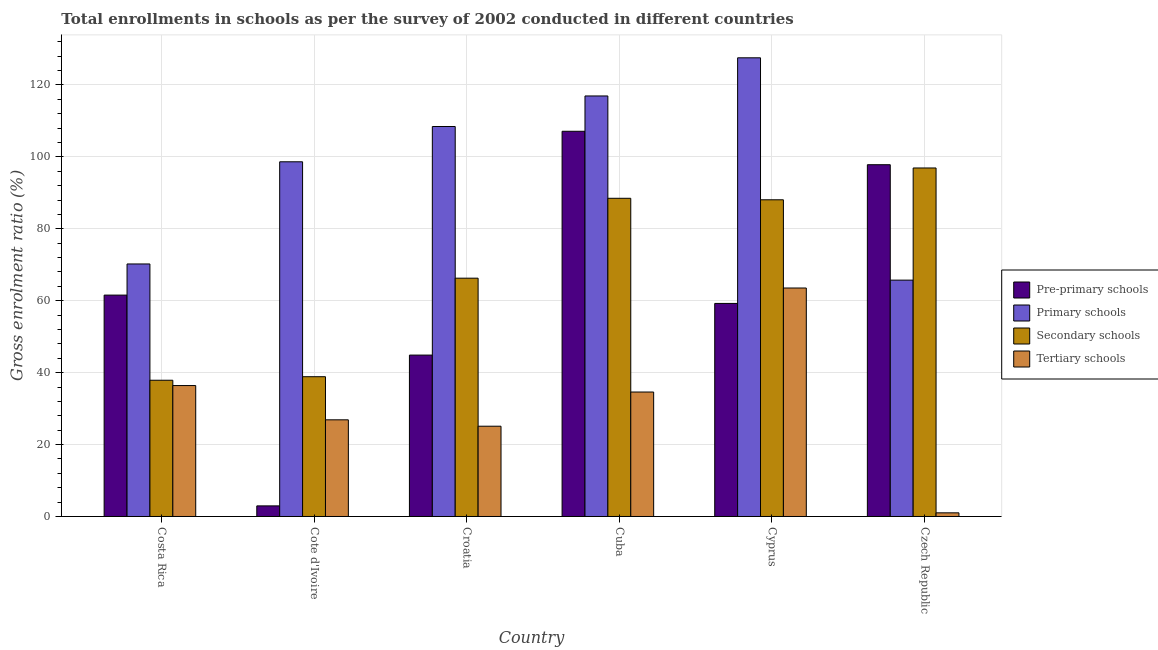How many different coloured bars are there?
Your answer should be compact. 4. Are the number of bars on each tick of the X-axis equal?
Give a very brief answer. Yes. How many bars are there on the 6th tick from the right?
Your response must be concise. 4. What is the label of the 2nd group of bars from the left?
Keep it short and to the point. Cote d'Ivoire. In how many cases, is the number of bars for a given country not equal to the number of legend labels?
Your answer should be compact. 0. What is the gross enrolment ratio in secondary schools in Cuba?
Provide a short and direct response. 88.49. Across all countries, what is the maximum gross enrolment ratio in tertiary schools?
Keep it short and to the point. 63.54. Across all countries, what is the minimum gross enrolment ratio in primary schools?
Offer a terse response. 65.73. In which country was the gross enrolment ratio in secondary schools maximum?
Provide a succinct answer. Czech Republic. In which country was the gross enrolment ratio in secondary schools minimum?
Give a very brief answer. Costa Rica. What is the total gross enrolment ratio in secondary schools in the graph?
Offer a terse response. 416.49. What is the difference between the gross enrolment ratio in pre-primary schools in Costa Rica and that in Croatia?
Provide a succinct answer. 16.68. What is the difference between the gross enrolment ratio in secondary schools in Croatia and the gross enrolment ratio in primary schools in Cuba?
Make the answer very short. -50.67. What is the average gross enrolment ratio in secondary schools per country?
Your answer should be compact. 69.42. What is the difference between the gross enrolment ratio in tertiary schools and gross enrolment ratio in primary schools in Costa Rica?
Offer a terse response. -33.81. In how many countries, is the gross enrolment ratio in primary schools greater than 72 %?
Offer a very short reply. 4. What is the ratio of the gross enrolment ratio in primary schools in Cote d'Ivoire to that in Cuba?
Provide a succinct answer. 0.84. Is the gross enrolment ratio in pre-primary schools in Cuba less than that in Cyprus?
Make the answer very short. No. What is the difference between the highest and the second highest gross enrolment ratio in primary schools?
Ensure brevity in your answer.  10.61. What is the difference between the highest and the lowest gross enrolment ratio in secondary schools?
Provide a succinct answer. 59.03. In how many countries, is the gross enrolment ratio in secondary schools greater than the average gross enrolment ratio in secondary schools taken over all countries?
Offer a very short reply. 3. What does the 2nd bar from the left in Czech Republic represents?
Offer a very short reply. Primary schools. What does the 3rd bar from the right in Cyprus represents?
Offer a terse response. Primary schools. Is it the case that in every country, the sum of the gross enrolment ratio in pre-primary schools and gross enrolment ratio in primary schools is greater than the gross enrolment ratio in secondary schools?
Make the answer very short. Yes. How many bars are there?
Provide a succinct answer. 24. Are all the bars in the graph horizontal?
Give a very brief answer. No. How many countries are there in the graph?
Make the answer very short. 6. Are the values on the major ticks of Y-axis written in scientific E-notation?
Ensure brevity in your answer.  No. Does the graph contain any zero values?
Offer a terse response. No. Where does the legend appear in the graph?
Provide a short and direct response. Center right. How many legend labels are there?
Your answer should be very brief. 4. What is the title of the graph?
Offer a very short reply. Total enrollments in schools as per the survey of 2002 conducted in different countries. Does "UNRWA" appear as one of the legend labels in the graph?
Your answer should be compact. No. What is the label or title of the X-axis?
Keep it short and to the point. Country. What is the label or title of the Y-axis?
Ensure brevity in your answer.  Gross enrolment ratio (%). What is the Gross enrolment ratio (%) in Pre-primary schools in Costa Rica?
Your answer should be compact. 61.56. What is the Gross enrolment ratio (%) in Primary schools in Costa Rica?
Your answer should be compact. 70.22. What is the Gross enrolment ratio (%) of Secondary schools in Costa Rica?
Your response must be concise. 37.89. What is the Gross enrolment ratio (%) of Tertiary schools in Costa Rica?
Give a very brief answer. 36.41. What is the Gross enrolment ratio (%) of Pre-primary schools in Cote d'Ivoire?
Your answer should be very brief. 2.95. What is the Gross enrolment ratio (%) in Primary schools in Cote d'Ivoire?
Your answer should be very brief. 98.63. What is the Gross enrolment ratio (%) of Secondary schools in Cote d'Ivoire?
Your answer should be compact. 38.87. What is the Gross enrolment ratio (%) in Tertiary schools in Cote d'Ivoire?
Your answer should be very brief. 26.88. What is the Gross enrolment ratio (%) in Pre-primary schools in Croatia?
Ensure brevity in your answer.  44.88. What is the Gross enrolment ratio (%) of Primary schools in Croatia?
Your answer should be very brief. 108.45. What is the Gross enrolment ratio (%) of Secondary schools in Croatia?
Ensure brevity in your answer.  66.27. What is the Gross enrolment ratio (%) in Tertiary schools in Croatia?
Provide a short and direct response. 25.1. What is the Gross enrolment ratio (%) in Pre-primary schools in Cuba?
Make the answer very short. 107.12. What is the Gross enrolment ratio (%) in Primary schools in Cuba?
Your answer should be very brief. 116.94. What is the Gross enrolment ratio (%) in Secondary schools in Cuba?
Ensure brevity in your answer.  88.49. What is the Gross enrolment ratio (%) of Tertiary schools in Cuba?
Provide a succinct answer. 34.61. What is the Gross enrolment ratio (%) in Pre-primary schools in Cyprus?
Ensure brevity in your answer.  59.25. What is the Gross enrolment ratio (%) of Primary schools in Cyprus?
Provide a short and direct response. 127.55. What is the Gross enrolment ratio (%) in Secondary schools in Cyprus?
Provide a succinct answer. 88.07. What is the Gross enrolment ratio (%) in Tertiary schools in Cyprus?
Provide a short and direct response. 63.54. What is the Gross enrolment ratio (%) in Pre-primary schools in Czech Republic?
Your answer should be very brief. 97.82. What is the Gross enrolment ratio (%) in Primary schools in Czech Republic?
Provide a succinct answer. 65.73. What is the Gross enrolment ratio (%) in Secondary schools in Czech Republic?
Provide a short and direct response. 96.92. What is the Gross enrolment ratio (%) of Tertiary schools in Czech Republic?
Make the answer very short. 1.02. Across all countries, what is the maximum Gross enrolment ratio (%) in Pre-primary schools?
Your answer should be compact. 107.12. Across all countries, what is the maximum Gross enrolment ratio (%) of Primary schools?
Ensure brevity in your answer.  127.55. Across all countries, what is the maximum Gross enrolment ratio (%) in Secondary schools?
Ensure brevity in your answer.  96.92. Across all countries, what is the maximum Gross enrolment ratio (%) in Tertiary schools?
Provide a succinct answer. 63.54. Across all countries, what is the minimum Gross enrolment ratio (%) of Pre-primary schools?
Your answer should be very brief. 2.95. Across all countries, what is the minimum Gross enrolment ratio (%) of Primary schools?
Keep it short and to the point. 65.73. Across all countries, what is the minimum Gross enrolment ratio (%) in Secondary schools?
Offer a very short reply. 37.89. Across all countries, what is the minimum Gross enrolment ratio (%) in Tertiary schools?
Offer a terse response. 1.02. What is the total Gross enrolment ratio (%) in Pre-primary schools in the graph?
Keep it short and to the point. 373.58. What is the total Gross enrolment ratio (%) in Primary schools in the graph?
Offer a very short reply. 587.52. What is the total Gross enrolment ratio (%) in Secondary schools in the graph?
Make the answer very short. 416.49. What is the total Gross enrolment ratio (%) of Tertiary schools in the graph?
Offer a terse response. 187.55. What is the difference between the Gross enrolment ratio (%) in Pre-primary schools in Costa Rica and that in Cote d'Ivoire?
Give a very brief answer. 58.62. What is the difference between the Gross enrolment ratio (%) in Primary schools in Costa Rica and that in Cote d'Ivoire?
Your answer should be very brief. -28.41. What is the difference between the Gross enrolment ratio (%) in Secondary schools in Costa Rica and that in Cote d'Ivoire?
Your answer should be very brief. -0.98. What is the difference between the Gross enrolment ratio (%) in Tertiary schools in Costa Rica and that in Cote d'Ivoire?
Keep it short and to the point. 9.53. What is the difference between the Gross enrolment ratio (%) of Pre-primary schools in Costa Rica and that in Croatia?
Keep it short and to the point. 16.68. What is the difference between the Gross enrolment ratio (%) in Primary schools in Costa Rica and that in Croatia?
Keep it short and to the point. -38.23. What is the difference between the Gross enrolment ratio (%) of Secondary schools in Costa Rica and that in Croatia?
Provide a succinct answer. -28.38. What is the difference between the Gross enrolment ratio (%) of Tertiary schools in Costa Rica and that in Croatia?
Offer a terse response. 11.31. What is the difference between the Gross enrolment ratio (%) of Pre-primary schools in Costa Rica and that in Cuba?
Keep it short and to the point. -45.56. What is the difference between the Gross enrolment ratio (%) of Primary schools in Costa Rica and that in Cuba?
Make the answer very short. -46.72. What is the difference between the Gross enrolment ratio (%) in Secondary schools in Costa Rica and that in Cuba?
Provide a succinct answer. -50.6. What is the difference between the Gross enrolment ratio (%) of Tertiary schools in Costa Rica and that in Cuba?
Make the answer very short. 1.8. What is the difference between the Gross enrolment ratio (%) in Pre-primary schools in Costa Rica and that in Cyprus?
Make the answer very short. 2.32. What is the difference between the Gross enrolment ratio (%) in Primary schools in Costa Rica and that in Cyprus?
Provide a succinct answer. -57.33. What is the difference between the Gross enrolment ratio (%) of Secondary schools in Costa Rica and that in Cyprus?
Your answer should be compact. -50.18. What is the difference between the Gross enrolment ratio (%) of Tertiary schools in Costa Rica and that in Cyprus?
Your answer should be compact. -27.13. What is the difference between the Gross enrolment ratio (%) of Pre-primary schools in Costa Rica and that in Czech Republic?
Offer a terse response. -36.26. What is the difference between the Gross enrolment ratio (%) of Primary schools in Costa Rica and that in Czech Republic?
Give a very brief answer. 4.5. What is the difference between the Gross enrolment ratio (%) of Secondary schools in Costa Rica and that in Czech Republic?
Offer a terse response. -59.03. What is the difference between the Gross enrolment ratio (%) of Tertiary schools in Costa Rica and that in Czech Republic?
Make the answer very short. 35.39. What is the difference between the Gross enrolment ratio (%) in Pre-primary schools in Cote d'Ivoire and that in Croatia?
Provide a succinct answer. -41.93. What is the difference between the Gross enrolment ratio (%) in Primary schools in Cote d'Ivoire and that in Croatia?
Keep it short and to the point. -9.81. What is the difference between the Gross enrolment ratio (%) in Secondary schools in Cote d'Ivoire and that in Croatia?
Make the answer very short. -27.4. What is the difference between the Gross enrolment ratio (%) in Tertiary schools in Cote d'Ivoire and that in Croatia?
Ensure brevity in your answer.  1.78. What is the difference between the Gross enrolment ratio (%) of Pre-primary schools in Cote d'Ivoire and that in Cuba?
Ensure brevity in your answer.  -104.17. What is the difference between the Gross enrolment ratio (%) of Primary schools in Cote d'Ivoire and that in Cuba?
Keep it short and to the point. -18.31. What is the difference between the Gross enrolment ratio (%) of Secondary schools in Cote d'Ivoire and that in Cuba?
Ensure brevity in your answer.  -49.62. What is the difference between the Gross enrolment ratio (%) in Tertiary schools in Cote d'Ivoire and that in Cuba?
Keep it short and to the point. -7.73. What is the difference between the Gross enrolment ratio (%) in Pre-primary schools in Cote d'Ivoire and that in Cyprus?
Your answer should be compact. -56.3. What is the difference between the Gross enrolment ratio (%) in Primary schools in Cote d'Ivoire and that in Cyprus?
Your response must be concise. -28.92. What is the difference between the Gross enrolment ratio (%) of Secondary schools in Cote d'Ivoire and that in Cyprus?
Offer a very short reply. -49.2. What is the difference between the Gross enrolment ratio (%) of Tertiary schools in Cote d'Ivoire and that in Cyprus?
Offer a terse response. -36.66. What is the difference between the Gross enrolment ratio (%) in Pre-primary schools in Cote d'Ivoire and that in Czech Republic?
Your answer should be very brief. -94.87. What is the difference between the Gross enrolment ratio (%) of Primary schools in Cote d'Ivoire and that in Czech Republic?
Make the answer very short. 32.91. What is the difference between the Gross enrolment ratio (%) in Secondary schools in Cote d'Ivoire and that in Czech Republic?
Your answer should be compact. -58.04. What is the difference between the Gross enrolment ratio (%) in Tertiary schools in Cote d'Ivoire and that in Czech Republic?
Offer a terse response. 25.86. What is the difference between the Gross enrolment ratio (%) of Pre-primary schools in Croatia and that in Cuba?
Give a very brief answer. -62.24. What is the difference between the Gross enrolment ratio (%) in Primary schools in Croatia and that in Cuba?
Your response must be concise. -8.49. What is the difference between the Gross enrolment ratio (%) in Secondary schools in Croatia and that in Cuba?
Provide a short and direct response. -22.22. What is the difference between the Gross enrolment ratio (%) in Tertiary schools in Croatia and that in Cuba?
Provide a succinct answer. -9.51. What is the difference between the Gross enrolment ratio (%) in Pre-primary schools in Croatia and that in Cyprus?
Ensure brevity in your answer.  -14.37. What is the difference between the Gross enrolment ratio (%) in Primary schools in Croatia and that in Cyprus?
Your response must be concise. -19.1. What is the difference between the Gross enrolment ratio (%) of Secondary schools in Croatia and that in Cyprus?
Keep it short and to the point. -21.8. What is the difference between the Gross enrolment ratio (%) in Tertiary schools in Croatia and that in Cyprus?
Provide a short and direct response. -38.43. What is the difference between the Gross enrolment ratio (%) of Pre-primary schools in Croatia and that in Czech Republic?
Provide a short and direct response. -52.94. What is the difference between the Gross enrolment ratio (%) in Primary schools in Croatia and that in Czech Republic?
Your answer should be very brief. 42.72. What is the difference between the Gross enrolment ratio (%) in Secondary schools in Croatia and that in Czech Republic?
Your answer should be very brief. -30.65. What is the difference between the Gross enrolment ratio (%) of Tertiary schools in Croatia and that in Czech Republic?
Your answer should be compact. 24.09. What is the difference between the Gross enrolment ratio (%) of Pre-primary schools in Cuba and that in Cyprus?
Provide a succinct answer. 47.87. What is the difference between the Gross enrolment ratio (%) of Primary schools in Cuba and that in Cyprus?
Keep it short and to the point. -10.61. What is the difference between the Gross enrolment ratio (%) in Secondary schools in Cuba and that in Cyprus?
Give a very brief answer. 0.42. What is the difference between the Gross enrolment ratio (%) of Tertiary schools in Cuba and that in Cyprus?
Ensure brevity in your answer.  -28.93. What is the difference between the Gross enrolment ratio (%) in Pre-primary schools in Cuba and that in Czech Republic?
Your answer should be compact. 9.3. What is the difference between the Gross enrolment ratio (%) of Primary schools in Cuba and that in Czech Republic?
Your answer should be compact. 51.22. What is the difference between the Gross enrolment ratio (%) in Secondary schools in Cuba and that in Czech Republic?
Offer a very short reply. -8.43. What is the difference between the Gross enrolment ratio (%) of Tertiary schools in Cuba and that in Czech Republic?
Make the answer very short. 33.59. What is the difference between the Gross enrolment ratio (%) of Pre-primary schools in Cyprus and that in Czech Republic?
Offer a very short reply. -38.57. What is the difference between the Gross enrolment ratio (%) in Primary schools in Cyprus and that in Czech Republic?
Provide a succinct answer. 61.82. What is the difference between the Gross enrolment ratio (%) of Secondary schools in Cyprus and that in Czech Republic?
Give a very brief answer. -8.85. What is the difference between the Gross enrolment ratio (%) of Tertiary schools in Cyprus and that in Czech Republic?
Offer a terse response. 62.52. What is the difference between the Gross enrolment ratio (%) in Pre-primary schools in Costa Rica and the Gross enrolment ratio (%) in Primary schools in Cote d'Ivoire?
Provide a short and direct response. -37.07. What is the difference between the Gross enrolment ratio (%) of Pre-primary schools in Costa Rica and the Gross enrolment ratio (%) of Secondary schools in Cote d'Ivoire?
Provide a short and direct response. 22.69. What is the difference between the Gross enrolment ratio (%) of Pre-primary schools in Costa Rica and the Gross enrolment ratio (%) of Tertiary schools in Cote d'Ivoire?
Give a very brief answer. 34.68. What is the difference between the Gross enrolment ratio (%) in Primary schools in Costa Rica and the Gross enrolment ratio (%) in Secondary schools in Cote d'Ivoire?
Your answer should be compact. 31.35. What is the difference between the Gross enrolment ratio (%) of Primary schools in Costa Rica and the Gross enrolment ratio (%) of Tertiary schools in Cote d'Ivoire?
Your answer should be compact. 43.34. What is the difference between the Gross enrolment ratio (%) in Secondary schools in Costa Rica and the Gross enrolment ratio (%) in Tertiary schools in Cote d'Ivoire?
Offer a very short reply. 11.01. What is the difference between the Gross enrolment ratio (%) in Pre-primary schools in Costa Rica and the Gross enrolment ratio (%) in Primary schools in Croatia?
Your answer should be very brief. -46.88. What is the difference between the Gross enrolment ratio (%) in Pre-primary schools in Costa Rica and the Gross enrolment ratio (%) in Secondary schools in Croatia?
Provide a short and direct response. -4.71. What is the difference between the Gross enrolment ratio (%) in Pre-primary schools in Costa Rica and the Gross enrolment ratio (%) in Tertiary schools in Croatia?
Keep it short and to the point. 36.46. What is the difference between the Gross enrolment ratio (%) of Primary schools in Costa Rica and the Gross enrolment ratio (%) of Secondary schools in Croatia?
Provide a short and direct response. 3.95. What is the difference between the Gross enrolment ratio (%) of Primary schools in Costa Rica and the Gross enrolment ratio (%) of Tertiary schools in Croatia?
Your answer should be compact. 45.12. What is the difference between the Gross enrolment ratio (%) in Secondary schools in Costa Rica and the Gross enrolment ratio (%) in Tertiary schools in Croatia?
Keep it short and to the point. 12.78. What is the difference between the Gross enrolment ratio (%) of Pre-primary schools in Costa Rica and the Gross enrolment ratio (%) of Primary schools in Cuba?
Your answer should be compact. -55.38. What is the difference between the Gross enrolment ratio (%) in Pre-primary schools in Costa Rica and the Gross enrolment ratio (%) in Secondary schools in Cuba?
Ensure brevity in your answer.  -26.92. What is the difference between the Gross enrolment ratio (%) of Pre-primary schools in Costa Rica and the Gross enrolment ratio (%) of Tertiary schools in Cuba?
Make the answer very short. 26.95. What is the difference between the Gross enrolment ratio (%) in Primary schools in Costa Rica and the Gross enrolment ratio (%) in Secondary schools in Cuba?
Give a very brief answer. -18.26. What is the difference between the Gross enrolment ratio (%) in Primary schools in Costa Rica and the Gross enrolment ratio (%) in Tertiary schools in Cuba?
Ensure brevity in your answer.  35.61. What is the difference between the Gross enrolment ratio (%) in Secondary schools in Costa Rica and the Gross enrolment ratio (%) in Tertiary schools in Cuba?
Make the answer very short. 3.28. What is the difference between the Gross enrolment ratio (%) of Pre-primary schools in Costa Rica and the Gross enrolment ratio (%) of Primary schools in Cyprus?
Provide a short and direct response. -65.99. What is the difference between the Gross enrolment ratio (%) in Pre-primary schools in Costa Rica and the Gross enrolment ratio (%) in Secondary schools in Cyprus?
Offer a terse response. -26.5. What is the difference between the Gross enrolment ratio (%) in Pre-primary schools in Costa Rica and the Gross enrolment ratio (%) in Tertiary schools in Cyprus?
Ensure brevity in your answer.  -1.97. What is the difference between the Gross enrolment ratio (%) in Primary schools in Costa Rica and the Gross enrolment ratio (%) in Secondary schools in Cyprus?
Your answer should be very brief. -17.84. What is the difference between the Gross enrolment ratio (%) in Primary schools in Costa Rica and the Gross enrolment ratio (%) in Tertiary schools in Cyprus?
Provide a short and direct response. 6.69. What is the difference between the Gross enrolment ratio (%) of Secondary schools in Costa Rica and the Gross enrolment ratio (%) of Tertiary schools in Cyprus?
Your answer should be very brief. -25.65. What is the difference between the Gross enrolment ratio (%) in Pre-primary schools in Costa Rica and the Gross enrolment ratio (%) in Primary schools in Czech Republic?
Offer a terse response. -4.16. What is the difference between the Gross enrolment ratio (%) of Pre-primary schools in Costa Rica and the Gross enrolment ratio (%) of Secondary schools in Czech Republic?
Provide a succinct answer. -35.35. What is the difference between the Gross enrolment ratio (%) of Pre-primary schools in Costa Rica and the Gross enrolment ratio (%) of Tertiary schools in Czech Republic?
Provide a succinct answer. 60.55. What is the difference between the Gross enrolment ratio (%) of Primary schools in Costa Rica and the Gross enrolment ratio (%) of Secondary schools in Czech Republic?
Make the answer very short. -26.69. What is the difference between the Gross enrolment ratio (%) in Primary schools in Costa Rica and the Gross enrolment ratio (%) in Tertiary schools in Czech Republic?
Keep it short and to the point. 69.2. What is the difference between the Gross enrolment ratio (%) of Secondary schools in Costa Rica and the Gross enrolment ratio (%) of Tertiary schools in Czech Republic?
Offer a very short reply. 36.87. What is the difference between the Gross enrolment ratio (%) of Pre-primary schools in Cote d'Ivoire and the Gross enrolment ratio (%) of Primary schools in Croatia?
Provide a succinct answer. -105.5. What is the difference between the Gross enrolment ratio (%) of Pre-primary schools in Cote d'Ivoire and the Gross enrolment ratio (%) of Secondary schools in Croatia?
Make the answer very short. -63.32. What is the difference between the Gross enrolment ratio (%) of Pre-primary schools in Cote d'Ivoire and the Gross enrolment ratio (%) of Tertiary schools in Croatia?
Provide a short and direct response. -22.16. What is the difference between the Gross enrolment ratio (%) in Primary schools in Cote d'Ivoire and the Gross enrolment ratio (%) in Secondary schools in Croatia?
Make the answer very short. 32.36. What is the difference between the Gross enrolment ratio (%) in Primary schools in Cote d'Ivoire and the Gross enrolment ratio (%) in Tertiary schools in Croatia?
Provide a short and direct response. 73.53. What is the difference between the Gross enrolment ratio (%) in Secondary schools in Cote d'Ivoire and the Gross enrolment ratio (%) in Tertiary schools in Croatia?
Keep it short and to the point. 13.77. What is the difference between the Gross enrolment ratio (%) in Pre-primary schools in Cote d'Ivoire and the Gross enrolment ratio (%) in Primary schools in Cuba?
Make the answer very short. -113.99. What is the difference between the Gross enrolment ratio (%) of Pre-primary schools in Cote d'Ivoire and the Gross enrolment ratio (%) of Secondary schools in Cuba?
Ensure brevity in your answer.  -85.54. What is the difference between the Gross enrolment ratio (%) in Pre-primary schools in Cote d'Ivoire and the Gross enrolment ratio (%) in Tertiary schools in Cuba?
Offer a terse response. -31.66. What is the difference between the Gross enrolment ratio (%) of Primary schools in Cote d'Ivoire and the Gross enrolment ratio (%) of Secondary schools in Cuba?
Your answer should be compact. 10.15. What is the difference between the Gross enrolment ratio (%) in Primary schools in Cote d'Ivoire and the Gross enrolment ratio (%) in Tertiary schools in Cuba?
Offer a terse response. 64.02. What is the difference between the Gross enrolment ratio (%) of Secondary schools in Cote d'Ivoire and the Gross enrolment ratio (%) of Tertiary schools in Cuba?
Your response must be concise. 4.26. What is the difference between the Gross enrolment ratio (%) in Pre-primary schools in Cote d'Ivoire and the Gross enrolment ratio (%) in Primary schools in Cyprus?
Your response must be concise. -124.6. What is the difference between the Gross enrolment ratio (%) of Pre-primary schools in Cote d'Ivoire and the Gross enrolment ratio (%) of Secondary schools in Cyprus?
Make the answer very short. -85.12. What is the difference between the Gross enrolment ratio (%) of Pre-primary schools in Cote d'Ivoire and the Gross enrolment ratio (%) of Tertiary schools in Cyprus?
Ensure brevity in your answer.  -60.59. What is the difference between the Gross enrolment ratio (%) of Primary schools in Cote d'Ivoire and the Gross enrolment ratio (%) of Secondary schools in Cyprus?
Your answer should be very brief. 10.57. What is the difference between the Gross enrolment ratio (%) in Primary schools in Cote d'Ivoire and the Gross enrolment ratio (%) in Tertiary schools in Cyprus?
Give a very brief answer. 35.1. What is the difference between the Gross enrolment ratio (%) in Secondary schools in Cote d'Ivoire and the Gross enrolment ratio (%) in Tertiary schools in Cyprus?
Give a very brief answer. -24.66. What is the difference between the Gross enrolment ratio (%) of Pre-primary schools in Cote d'Ivoire and the Gross enrolment ratio (%) of Primary schools in Czech Republic?
Your answer should be very brief. -62.78. What is the difference between the Gross enrolment ratio (%) of Pre-primary schools in Cote d'Ivoire and the Gross enrolment ratio (%) of Secondary schools in Czech Republic?
Ensure brevity in your answer.  -93.97. What is the difference between the Gross enrolment ratio (%) of Pre-primary schools in Cote d'Ivoire and the Gross enrolment ratio (%) of Tertiary schools in Czech Republic?
Your response must be concise. 1.93. What is the difference between the Gross enrolment ratio (%) in Primary schools in Cote d'Ivoire and the Gross enrolment ratio (%) in Secondary schools in Czech Republic?
Your response must be concise. 1.72. What is the difference between the Gross enrolment ratio (%) in Primary schools in Cote d'Ivoire and the Gross enrolment ratio (%) in Tertiary schools in Czech Republic?
Your answer should be compact. 97.62. What is the difference between the Gross enrolment ratio (%) of Secondary schools in Cote d'Ivoire and the Gross enrolment ratio (%) of Tertiary schools in Czech Republic?
Make the answer very short. 37.85. What is the difference between the Gross enrolment ratio (%) in Pre-primary schools in Croatia and the Gross enrolment ratio (%) in Primary schools in Cuba?
Provide a short and direct response. -72.06. What is the difference between the Gross enrolment ratio (%) in Pre-primary schools in Croatia and the Gross enrolment ratio (%) in Secondary schools in Cuba?
Ensure brevity in your answer.  -43.61. What is the difference between the Gross enrolment ratio (%) of Pre-primary schools in Croatia and the Gross enrolment ratio (%) of Tertiary schools in Cuba?
Your answer should be compact. 10.27. What is the difference between the Gross enrolment ratio (%) in Primary schools in Croatia and the Gross enrolment ratio (%) in Secondary schools in Cuba?
Give a very brief answer. 19.96. What is the difference between the Gross enrolment ratio (%) in Primary schools in Croatia and the Gross enrolment ratio (%) in Tertiary schools in Cuba?
Make the answer very short. 73.84. What is the difference between the Gross enrolment ratio (%) of Secondary schools in Croatia and the Gross enrolment ratio (%) of Tertiary schools in Cuba?
Offer a terse response. 31.66. What is the difference between the Gross enrolment ratio (%) of Pre-primary schools in Croatia and the Gross enrolment ratio (%) of Primary schools in Cyprus?
Provide a short and direct response. -82.67. What is the difference between the Gross enrolment ratio (%) in Pre-primary schools in Croatia and the Gross enrolment ratio (%) in Secondary schools in Cyprus?
Offer a terse response. -43.19. What is the difference between the Gross enrolment ratio (%) of Pre-primary schools in Croatia and the Gross enrolment ratio (%) of Tertiary schools in Cyprus?
Your answer should be compact. -18.66. What is the difference between the Gross enrolment ratio (%) in Primary schools in Croatia and the Gross enrolment ratio (%) in Secondary schools in Cyprus?
Give a very brief answer. 20.38. What is the difference between the Gross enrolment ratio (%) of Primary schools in Croatia and the Gross enrolment ratio (%) of Tertiary schools in Cyprus?
Make the answer very short. 44.91. What is the difference between the Gross enrolment ratio (%) of Secondary schools in Croatia and the Gross enrolment ratio (%) of Tertiary schools in Cyprus?
Your response must be concise. 2.73. What is the difference between the Gross enrolment ratio (%) of Pre-primary schools in Croatia and the Gross enrolment ratio (%) of Primary schools in Czech Republic?
Give a very brief answer. -20.85. What is the difference between the Gross enrolment ratio (%) in Pre-primary schools in Croatia and the Gross enrolment ratio (%) in Secondary schools in Czech Republic?
Keep it short and to the point. -52.04. What is the difference between the Gross enrolment ratio (%) of Pre-primary schools in Croatia and the Gross enrolment ratio (%) of Tertiary schools in Czech Republic?
Ensure brevity in your answer.  43.86. What is the difference between the Gross enrolment ratio (%) of Primary schools in Croatia and the Gross enrolment ratio (%) of Secondary schools in Czech Republic?
Your answer should be compact. 11.53. What is the difference between the Gross enrolment ratio (%) of Primary schools in Croatia and the Gross enrolment ratio (%) of Tertiary schools in Czech Republic?
Your answer should be very brief. 107.43. What is the difference between the Gross enrolment ratio (%) of Secondary schools in Croatia and the Gross enrolment ratio (%) of Tertiary schools in Czech Republic?
Give a very brief answer. 65.25. What is the difference between the Gross enrolment ratio (%) in Pre-primary schools in Cuba and the Gross enrolment ratio (%) in Primary schools in Cyprus?
Your answer should be very brief. -20.43. What is the difference between the Gross enrolment ratio (%) of Pre-primary schools in Cuba and the Gross enrolment ratio (%) of Secondary schools in Cyprus?
Ensure brevity in your answer.  19.05. What is the difference between the Gross enrolment ratio (%) of Pre-primary schools in Cuba and the Gross enrolment ratio (%) of Tertiary schools in Cyprus?
Offer a very short reply. 43.58. What is the difference between the Gross enrolment ratio (%) of Primary schools in Cuba and the Gross enrolment ratio (%) of Secondary schools in Cyprus?
Offer a terse response. 28.88. What is the difference between the Gross enrolment ratio (%) of Primary schools in Cuba and the Gross enrolment ratio (%) of Tertiary schools in Cyprus?
Your answer should be compact. 53.41. What is the difference between the Gross enrolment ratio (%) in Secondary schools in Cuba and the Gross enrolment ratio (%) in Tertiary schools in Cyprus?
Give a very brief answer. 24.95. What is the difference between the Gross enrolment ratio (%) of Pre-primary schools in Cuba and the Gross enrolment ratio (%) of Primary schools in Czech Republic?
Provide a succinct answer. 41.39. What is the difference between the Gross enrolment ratio (%) of Pre-primary schools in Cuba and the Gross enrolment ratio (%) of Secondary schools in Czech Republic?
Offer a very short reply. 10.2. What is the difference between the Gross enrolment ratio (%) of Pre-primary schools in Cuba and the Gross enrolment ratio (%) of Tertiary schools in Czech Republic?
Offer a very short reply. 106.1. What is the difference between the Gross enrolment ratio (%) of Primary schools in Cuba and the Gross enrolment ratio (%) of Secondary schools in Czech Republic?
Provide a succinct answer. 20.03. What is the difference between the Gross enrolment ratio (%) in Primary schools in Cuba and the Gross enrolment ratio (%) in Tertiary schools in Czech Republic?
Give a very brief answer. 115.92. What is the difference between the Gross enrolment ratio (%) of Secondary schools in Cuba and the Gross enrolment ratio (%) of Tertiary schools in Czech Republic?
Offer a terse response. 87.47. What is the difference between the Gross enrolment ratio (%) of Pre-primary schools in Cyprus and the Gross enrolment ratio (%) of Primary schools in Czech Republic?
Provide a short and direct response. -6.48. What is the difference between the Gross enrolment ratio (%) in Pre-primary schools in Cyprus and the Gross enrolment ratio (%) in Secondary schools in Czech Republic?
Keep it short and to the point. -37.67. What is the difference between the Gross enrolment ratio (%) of Pre-primary schools in Cyprus and the Gross enrolment ratio (%) of Tertiary schools in Czech Republic?
Provide a succinct answer. 58.23. What is the difference between the Gross enrolment ratio (%) of Primary schools in Cyprus and the Gross enrolment ratio (%) of Secondary schools in Czech Republic?
Ensure brevity in your answer.  30.63. What is the difference between the Gross enrolment ratio (%) in Primary schools in Cyprus and the Gross enrolment ratio (%) in Tertiary schools in Czech Republic?
Your response must be concise. 126.53. What is the difference between the Gross enrolment ratio (%) of Secondary schools in Cyprus and the Gross enrolment ratio (%) of Tertiary schools in Czech Republic?
Your answer should be very brief. 87.05. What is the average Gross enrolment ratio (%) of Pre-primary schools per country?
Ensure brevity in your answer.  62.26. What is the average Gross enrolment ratio (%) in Primary schools per country?
Make the answer very short. 97.92. What is the average Gross enrolment ratio (%) of Secondary schools per country?
Ensure brevity in your answer.  69.42. What is the average Gross enrolment ratio (%) in Tertiary schools per country?
Your answer should be very brief. 31.26. What is the difference between the Gross enrolment ratio (%) in Pre-primary schools and Gross enrolment ratio (%) in Primary schools in Costa Rica?
Make the answer very short. -8.66. What is the difference between the Gross enrolment ratio (%) of Pre-primary schools and Gross enrolment ratio (%) of Secondary schools in Costa Rica?
Ensure brevity in your answer.  23.68. What is the difference between the Gross enrolment ratio (%) in Pre-primary schools and Gross enrolment ratio (%) in Tertiary schools in Costa Rica?
Your response must be concise. 25.15. What is the difference between the Gross enrolment ratio (%) of Primary schools and Gross enrolment ratio (%) of Secondary schools in Costa Rica?
Offer a very short reply. 32.34. What is the difference between the Gross enrolment ratio (%) of Primary schools and Gross enrolment ratio (%) of Tertiary schools in Costa Rica?
Your response must be concise. 33.81. What is the difference between the Gross enrolment ratio (%) in Secondary schools and Gross enrolment ratio (%) in Tertiary schools in Costa Rica?
Keep it short and to the point. 1.48. What is the difference between the Gross enrolment ratio (%) in Pre-primary schools and Gross enrolment ratio (%) in Primary schools in Cote d'Ivoire?
Provide a short and direct response. -95.69. What is the difference between the Gross enrolment ratio (%) in Pre-primary schools and Gross enrolment ratio (%) in Secondary schools in Cote d'Ivoire?
Your answer should be very brief. -35.92. What is the difference between the Gross enrolment ratio (%) of Pre-primary schools and Gross enrolment ratio (%) of Tertiary schools in Cote d'Ivoire?
Your answer should be very brief. -23.93. What is the difference between the Gross enrolment ratio (%) of Primary schools and Gross enrolment ratio (%) of Secondary schools in Cote d'Ivoire?
Offer a very short reply. 59.76. What is the difference between the Gross enrolment ratio (%) of Primary schools and Gross enrolment ratio (%) of Tertiary schools in Cote d'Ivoire?
Make the answer very short. 71.75. What is the difference between the Gross enrolment ratio (%) of Secondary schools and Gross enrolment ratio (%) of Tertiary schools in Cote d'Ivoire?
Offer a very short reply. 11.99. What is the difference between the Gross enrolment ratio (%) in Pre-primary schools and Gross enrolment ratio (%) in Primary schools in Croatia?
Provide a short and direct response. -63.57. What is the difference between the Gross enrolment ratio (%) of Pre-primary schools and Gross enrolment ratio (%) of Secondary schools in Croatia?
Provide a short and direct response. -21.39. What is the difference between the Gross enrolment ratio (%) in Pre-primary schools and Gross enrolment ratio (%) in Tertiary schools in Croatia?
Your response must be concise. 19.78. What is the difference between the Gross enrolment ratio (%) of Primary schools and Gross enrolment ratio (%) of Secondary schools in Croatia?
Keep it short and to the point. 42.18. What is the difference between the Gross enrolment ratio (%) of Primary schools and Gross enrolment ratio (%) of Tertiary schools in Croatia?
Your answer should be very brief. 83.34. What is the difference between the Gross enrolment ratio (%) in Secondary schools and Gross enrolment ratio (%) in Tertiary schools in Croatia?
Your answer should be compact. 41.17. What is the difference between the Gross enrolment ratio (%) of Pre-primary schools and Gross enrolment ratio (%) of Primary schools in Cuba?
Provide a succinct answer. -9.82. What is the difference between the Gross enrolment ratio (%) of Pre-primary schools and Gross enrolment ratio (%) of Secondary schools in Cuba?
Offer a very short reply. 18.63. What is the difference between the Gross enrolment ratio (%) of Pre-primary schools and Gross enrolment ratio (%) of Tertiary schools in Cuba?
Ensure brevity in your answer.  72.51. What is the difference between the Gross enrolment ratio (%) of Primary schools and Gross enrolment ratio (%) of Secondary schools in Cuba?
Make the answer very short. 28.46. What is the difference between the Gross enrolment ratio (%) of Primary schools and Gross enrolment ratio (%) of Tertiary schools in Cuba?
Provide a succinct answer. 82.33. What is the difference between the Gross enrolment ratio (%) in Secondary schools and Gross enrolment ratio (%) in Tertiary schools in Cuba?
Provide a short and direct response. 53.88. What is the difference between the Gross enrolment ratio (%) of Pre-primary schools and Gross enrolment ratio (%) of Primary schools in Cyprus?
Offer a very short reply. -68.3. What is the difference between the Gross enrolment ratio (%) in Pre-primary schools and Gross enrolment ratio (%) in Secondary schools in Cyprus?
Make the answer very short. -28.82. What is the difference between the Gross enrolment ratio (%) of Pre-primary schools and Gross enrolment ratio (%) of Tertiary schools in Cyprus?
Your answer should be compact. -4.29. What is the difference between the Gross enrolment ratio (%) of Primary schools and Gross enrolment ratio (%) of Secondary schools in Cyprus?
Make the answer very short. 39.48. What is the difference between the Gross enrolment ratio (%) of Primary schools and Gross enrolment ratio (%) of Tertiary schools in Cyprus?
Give a very brief answer. 64.01. What is the difference between the Gross enrolment ratio (%) of Secondary schools and Gross enrolment ratio (%) of Tertiary schools in Cyprus?
Keep it short and to the point. 24.53. What is the difference between the Gross enrolment ratio (%) of Pre-primary schools and Gross enrolment ratio (%) of Primary schools in Czech Republic?
Provide a succinct answer. 32.1. What is the difference between the Gross enrolment ratio (%) in Pre-primary schools and Gross enrolment ratio (%) in Secondary schools in Czech Republic?
Your response must be concise. 0.91. What is the difference between the Gross enrolment ratio (%) of Pre-primary schools and Gross enrolment ratio (%) of Tertiary schools in Czech Republic?
Your answer should be compact. 96.8. What is the difference between the Gross enrolment ratio (%) in Primary schools and Gross enrolment ratio (%) in Secondary schools in Czech Republic?
Offer a very short reply. -31.19. What is the difference between the Gross enrolment ratio (%) of Primary schools and Gross enrolment ratio (%) of Tertiary schools in Czech Republic?
Your answer should be very brief. 64.71. What is the difference between the Gross enrolment ratio (%) in Secondary schools and Gross enrolment ratio (%) in Tertiary schools in Czech Republic?
Offer a terse response. 95.9. What is the ratio of the Gross enrolment ratio (%) of Pre-primary schools in Costa Rica to that in Cote d'Ivoire?
Your answer should be compact. 20.89. What is the ratio of the Gross enrolment ratio (%) of Primary schools in Costa Rica to that in Cote d'Ivoire?
Offer a terse response. 0.71. What is the ratio of the Gross enrolment ratio (%) of Secondary schools in Costa Rica to that in Cote d'Ivoire?
Offer a terse response. 0.97. What is the ratio of the Gross enrolment ratio (%) of Tertiary schools in Costa Rica to that in Cote d'Ivoire?
Your answer should be compact. 1.35. What is the ratio of the Gross enrolment ratio (%) of Pre-primary schools in Costa Rica to that in Croatia?
Make the answer very short. 1.37. What is the ratio of the Gross enrolment ratio (%) of Primary schools in Costa Rica to that in Croatia?
Your answer should be very brief. 0.65. What is the ratio of the Gross enrolment ratio (%) of Secondary schools in Costa Rica to that in Croatia?
Keep it short and to the point. 0.57. What is the ratio of the Gross enrolment ratio (%) of Tertiary schools in Costa Rica to that in Croatia?
Provide a short and direct response. 1.45. What is the ratio of the Gross enrolment ratio (%) of Pre-primary schools in Costa Rica to that in Cuba?
Provide a succinct answer. 0.57. What is the ratio of the Gross enrolment ratio (%) of Primary schools in Costa Rica to that in Cuba?
Provide a succinct answer. 0.6. What is the ratio of the Gross enrolment ratio (%) of Secondary schools in Costa Rica to that in Cuba?
Give a very brief answer. 0.43. What is the ratio of the Gross enrolment ratio (%) of Tertiary schools in Costa Rica to that in Cuba?
Offer a very short reply. 1.05. What is the ratio of the Gross enrolment ratio (%) in Pre-primary schools in Costa Rica to that in Cyprus?
Offer a very short reply. 1.04. What is the ratio of the Gross enrolment ratio (%) in Primary schools in Costa Rica to that in Cyprus?
Your answer should be very brief. 0.55. What is the ratio of the Gross enrolment ratio (%) in Secondary schools in Costa Rica to that in Cyprus?
Ensure brevity in your answer.  0.43. What is the ratio of the Gross enrolment ratio (%) of Tertiary schools in Costa Rica to that in Cyprus?
Ensure brevity in your answer.  0.57. What is the ratio of the Gross enrolment ratio (%) in Pre-primary schools in Costa Rica to that in Czech Republic?
Keep it short and to the point. 0.63. What is the ratio of the Gross enrolment ratio (%) of Primary schools in Costa Rica to that in Czech Republic?
Provide a short and direct response. 1.07. What is the ratio of the Gross enrolment ratio (%) in Secondary schools in Costa Rica to that in Czech Republic?
Keep it short and to the point. 0.39. What is the ratio of the Gross enrolment ratio (%) in Tertiary schools in Costa Rica to that in Czech Republic?
Keep it short and to the point. 35.82. What is the ratio of the Gross enrolment ratio (%) of Pre-primary schools in Cote d'Ivoire to that in Croatia?
Your answer should be compact. 0.07. What is the ratio of the Gross enrolment ratio (%) of Primary schools in Cote d'Ivoire to that in Croatia?
Offer a very short reply. 0.91. What is the ratio of the Gross enrolment ratio (%) in Secondary schools in Cote d'Ivoire to that in Croatia?
Provide a succinct answer. 0.59. What is the ratio of the Gross enrolment ratio (%) in Tertiary schools in Cote d'Ivoire to that in Croatia?
Ensure brevity in your answer.  1.07. What is the ratio of the Gross enrolment ratio (%) of Pre-primary schools in Cote d'Ivoire to that in Cuba?
Offer a very short reply. 0.03. What is the ratio of the Gross enrolment ratio (%) of Primary schools in Cote d'Ivoire to that in Cuba?
Your answer should be very brief. 0.84. What is the ratio of the Gross enrolment ratio (%) in Secondary schools in Cote d'Ivoire to that in Cuba?
Your answer should be very brief. 0.44. What is the ratio of the Gross enrolment ratio (%) of Tertiary schools in Cote d'Ivoire to that in Cuba?
Your answer should be very brief. 0.78. What is the ratio of the Gross enrolment ratio (%) of Pre-primary schools in Cote d'Ivoire to that in Cyprus?
Keep it short and to the point. 0.05. What is the ratio of the Gross enrolment ratio (%) of Primary schools in Cote d'Ivoire to that in Cyprus?
Offer a terse response. 0.77. What is the ratio of the Gross enrolment ratio (%) in Secondary schools in Cote d'Ivoire to that in Cyprus?
Offer a very short reply. 0.44. What is the ratio of the Gross enrolment ratio (%) in Tertiary schools in Cote d'Ivoire to that in Cyprus?
Offer a very short reply. 0.42. What is the ratio of the Gross enrolment ratio (%) of Pre-primary schools in Cote d'Ivoire to that in Czech Republic?
Your answer should be compact. 0.03. What is the ratio of the Gross enrolment ratio (%) of Primary schools in Cote d'Ivoire to that in Czech Republic?
Keep it short and to the point. 1.5. What is the ratio of the Gross enrolment ratio (%) in Secondary schools in Cote d'Ivoire to that in Czech Republic?
Offer a very short reply. 0.4. What is the ratio of the Gross enrolment ratio (%) in Tertiary schools in Cote d'Ivoire to that in Czech Republic?
Your response must be concise. 26.44. What is the ratio of the Gross enrolment ratio (%) in Pre-primary schools in Croatia to that in Cuba?
Your response must be concise. 0.42. What is the ratio of the Gross enrolment ratio (%) in Primary schools in Croatia to that in Cuba?
Your answer should be very brief. 0.93. What is the ratio of the Gross enrolment ratio (%) of Secondary schools in Croatia to that in Cuba?
Provide a succinct answer. 0.75. What is the ratio of the Gross enrolment ratio (%) in Tertiary schools in Croatia to that in Cuba?
Your answer should be very brief. 0.73. What is the ratio of the Gross enrolment ratio (%) of Pre-primary schools in Croatia to that in Cyprus?
Provide a succinct answer. 0.76. What is the ratio of the Gross enrolment ratio (%) in Primary schools in Croatia to that in Cyprus?
Provide a short and direct response. 0.85. What is the ratio of the Gross enrolment ratio (%) in Secondary schools in Croatia to that in Cyprus?
Your answer should be very brief. 0.75. What is the ratio of the Gross enrolment ratio (%) of Tertiary schools in Croatia to that in Cyprus?
Your answer should be very brief. 0.4. What is the ratio of the Gross enrolment ratio (%) of Pre-primary schools in Croatia to that in Czech Republic?
Keep it short and to the point. 0.46. What is the ratio of the Gross enrolment ratio (%) in Primary schools in Croatia to that in Czech Republic?
Make the answer very short. 1.65. What is the ratio of the Gross enrolment ratio (%) of Secondary schools in Croatia to that in Czech Republic?
Offer a terse response. 0.68. What is the ratio of the Gross enrolment ratio (%) in Tertiary schools in Croatia to that in Czech Republic?
Make the answer very short. 24.69. What is the ratio of the Gross enrolment ratio (%) in Pre-primary schools in Cuba to that in Cyprus?
Offer a very short reply. 1.81. What is the ratio of the Gross enrolment ratio (%) of Primary schools in Cuba to that in Cyprus?
Your response must be concise. 0.92. What is the ratio of the Gross enrolment ratio (%) of Tertiary schools in Cuba to that in Cyprus?
Your response must be concise. 0.54. What is the ratio of the Gross enrolment ratio (%) of Pre-primary schools in Cuba to that in Czech Republic?
Offer a very short reply. 1.1. What is the ratio of the Gross enrolment ratio (%) of Primary schools in Cuba to that in Czech Republic?
Offer a very short reply. 1.78. What is the ratio of the Gross enrolment ratio (%) of Tertiary schools in Cuba to that in Czech Republic?
Your answer should be very brief. 34.05. What is the ratio of the Gross enrolment ratio (%) of Pre-primary schools in Cyprus to that in Czech Republic?
Ensure brevity in your answer.  0.61. What is the ratio of the Gross enrolment ratio (%) of Primary schools in Cyprus to that in Czech Republic?
Your answer should be very brief. 1.94. What is the ratio of the Gross enrolment ratio (%) in Secondary schools in Cyprus to that in Czech Republic?
Make the answer very short. 0.91. What is the ratio of the Gross enrolment ratio (%) in Tertiary schools in Cyprus to that in Czech Republic?
Give a very brief answer. 62.5. What is the difference between the highest and the second highest Gross enrolment ratio (%) of Pre-primary schools?
Make the answer very short. 9.3. What is the difference between the highest and the second highest Gross enrolment ratio (%) in Primary schools?
Offer a terse response. 10.61. What is the difference between the highest and the second highest Gross enrolment ratio (%) of Secondary schools?
Offer a terse response. 8.43. What is the difference between the highest and the second highest Gross enrolment ratio (%) in Tertiary schools?
Provide a short and direct response. 27.13. What is the difference between the highest and the lowest Gross enrolment ratio (%) in Pre-primary schools?
Ensure brevity in your answer.  104.17. What is the difference between the highest and the lowest Gross enrolment ratio (%) in Primary schools?
Offer a terse response. 61.82. What is the difference between the highest and the lowest Gross enrolment ratio (%) of Secondary schools?
Your answer should be very brief. 59.03. What is the difference between the highest and the lowest Gross enrolment ratio (%) of Tertiary schools?
Provide a short and direct response. 62.52. 